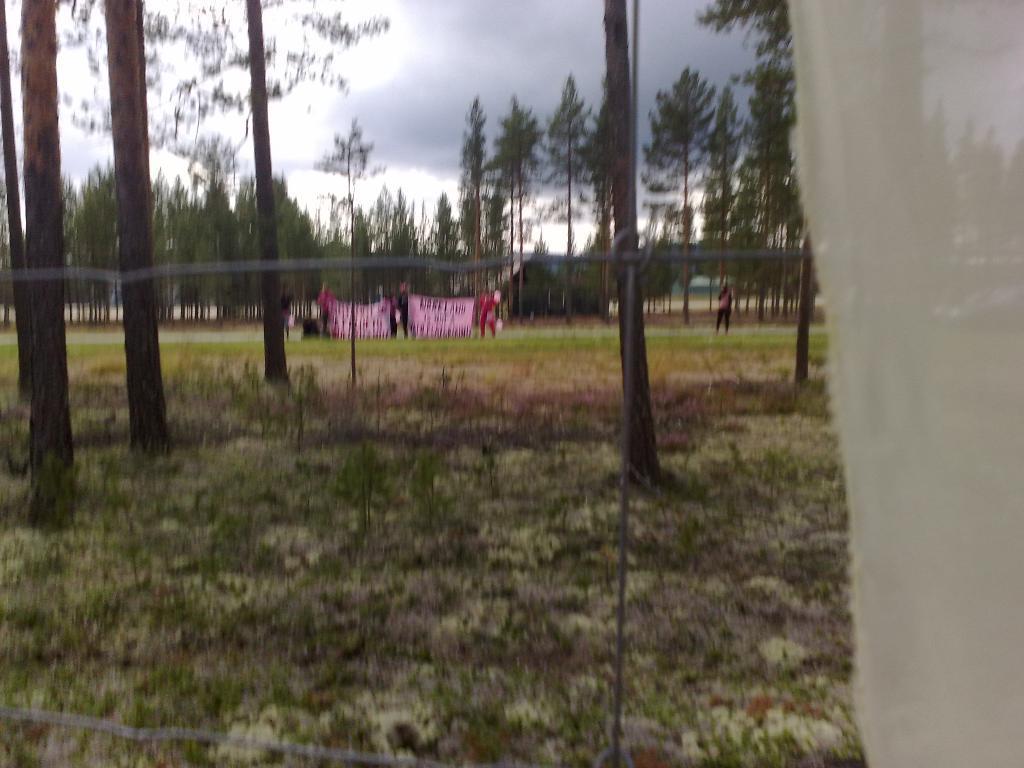Can you describe this image briefly? This picture is blur, we can see grass, plants and trees. In the background we can see people, banner, trees and sky with clouds. 